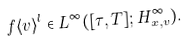<formula> <loc_0><loc_0><loc_500><loc_500>f \langle v \rangle ^ { l } \in L ^ { \infty } ( [ \tau , T ] ; H ^ { \infty } _ { x , v } ) .</formula> 